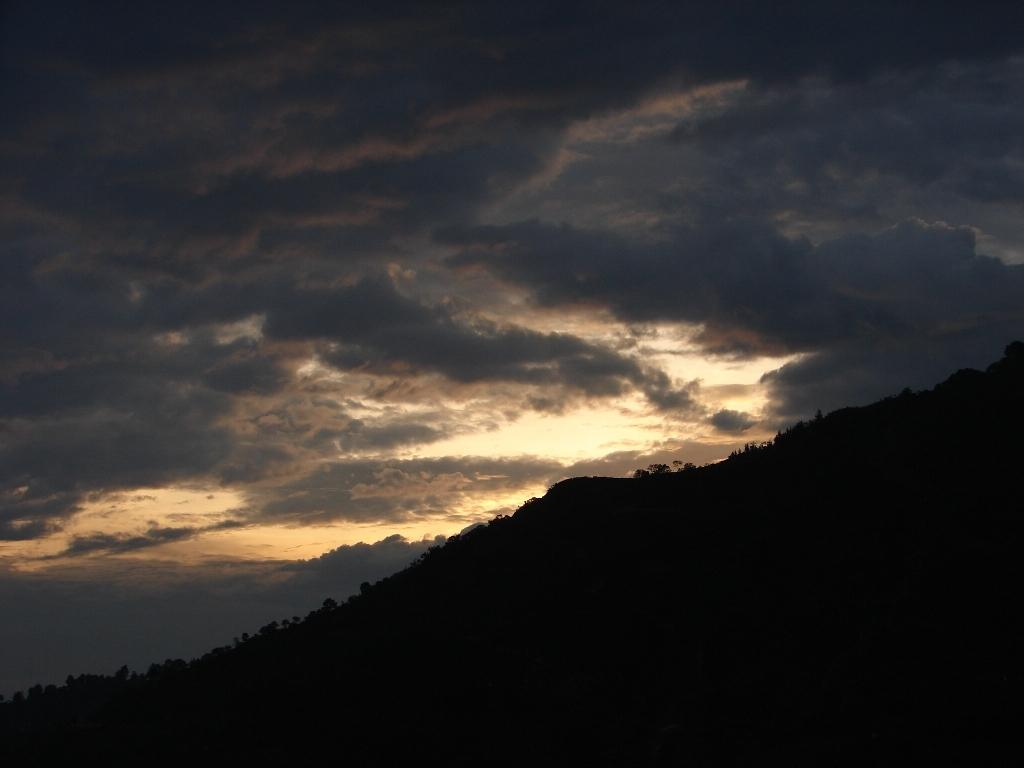What type of vegetation can be seen in the image? There are trees in the image. What can be seen in the sky in the image? There are clouds in the image. What type of organization is depicted in the image? There is no organization depicted in the image; it features trees and clouds. Can you tell me what kind of rod is being used by the animal in the image? There is no animal or rod present in the image. 